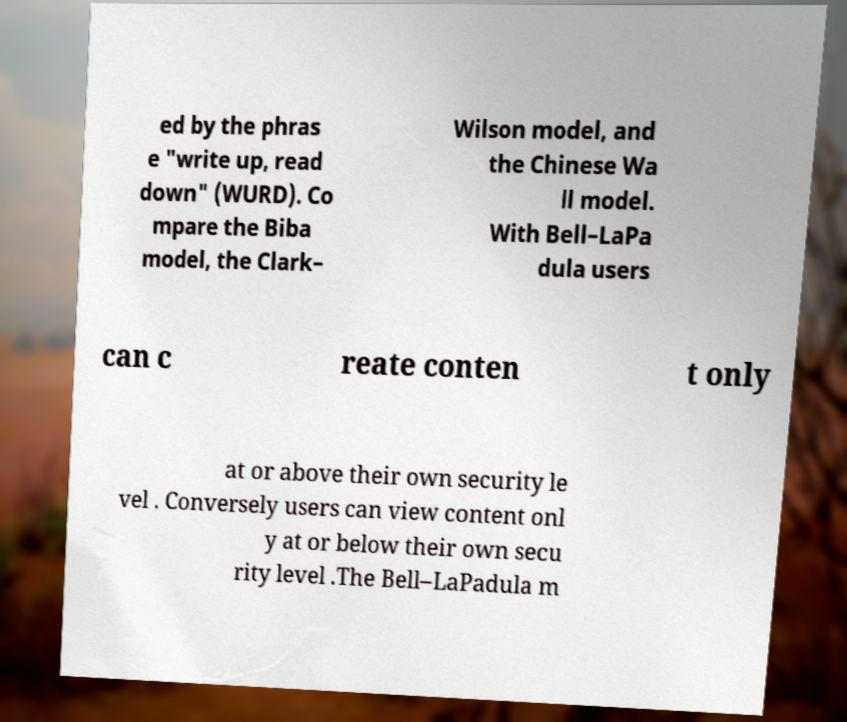Please identify and transcribe the text found in this image. ed by the phras e "write up, read down" (WURD). Co mpare the Biba model, the Clark– Wilson model, and the Chinese Wa ll model. With Bell–LaPa dula users can c reate conten t only at or above their own security le vel . Conversely users can view content onl y at or below their own secu rity level .The Bell–LaPadula m 